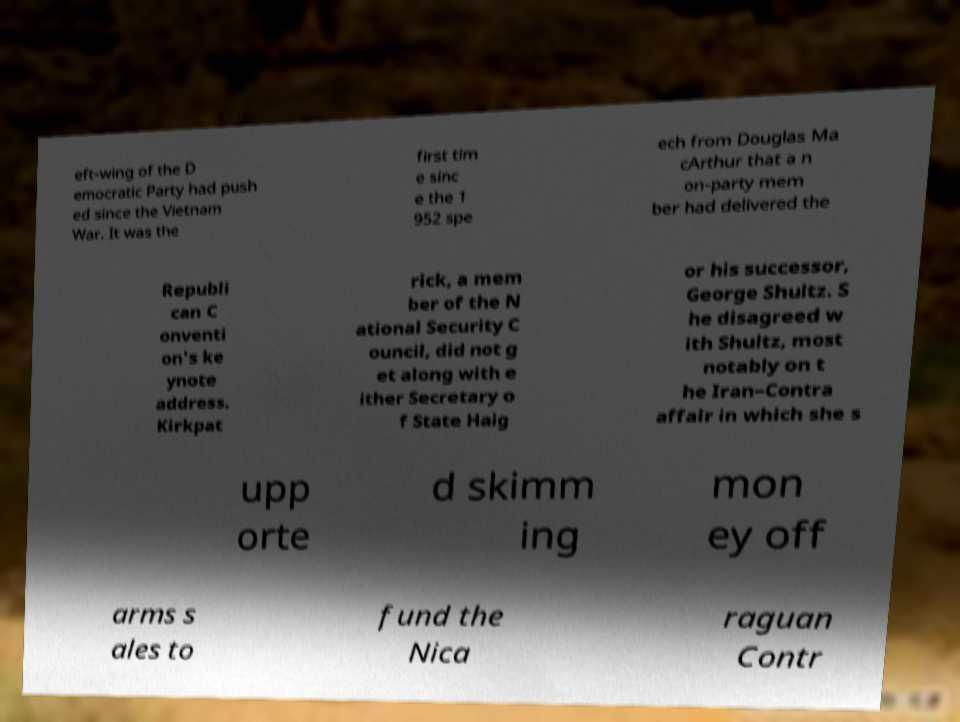I need the written content from this picture converted into text. Can you do that? eft-wing of the D emocratic Party had push ed since the Vietnam War. It was the first tim e sinc e the 1 952 spe ech from Douglas Ma cArthur that a n on-party mem ber had delivered the Republi can C onventi on's ke ynote address. Kirkpat rick, a mem ber of the N ational Security C ouncil, did not g et along with e ither Secretary o f State Haig or his successor, George Shultz. S he disagreed w ith Shultz, most notably on t he Iran–Contra affair in which she s upp orte d skimm ing mon ey off arms s ales to fund the Nica raguan Contr 